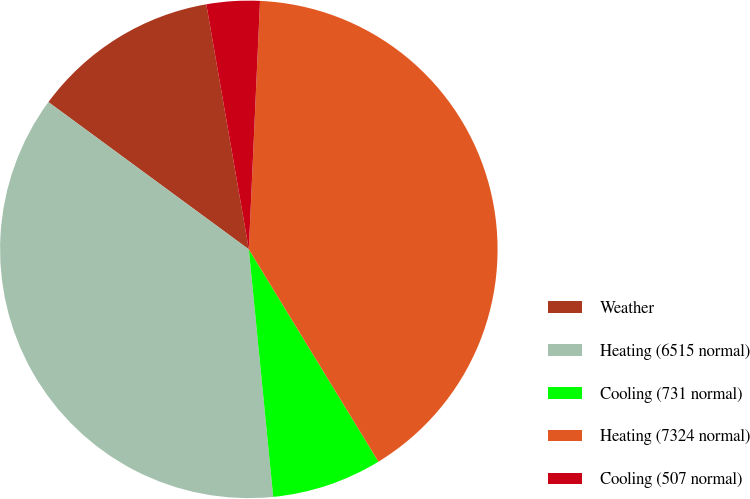Convert chart. <chart><loc_0><loc_0><loc_500><loc_500><pie_chart><fcel>Weather<fcel>Heating (6515 normal)<fcel>Cooling (731 normal)<fcel>Heating (7324 normal)<fcel>Cooling (507 normal)<nl><fcel>12.18%<fcel>36.65%<fcel>7.16%<fcel>40.56%<fcel>3.45%<nl></chart> 